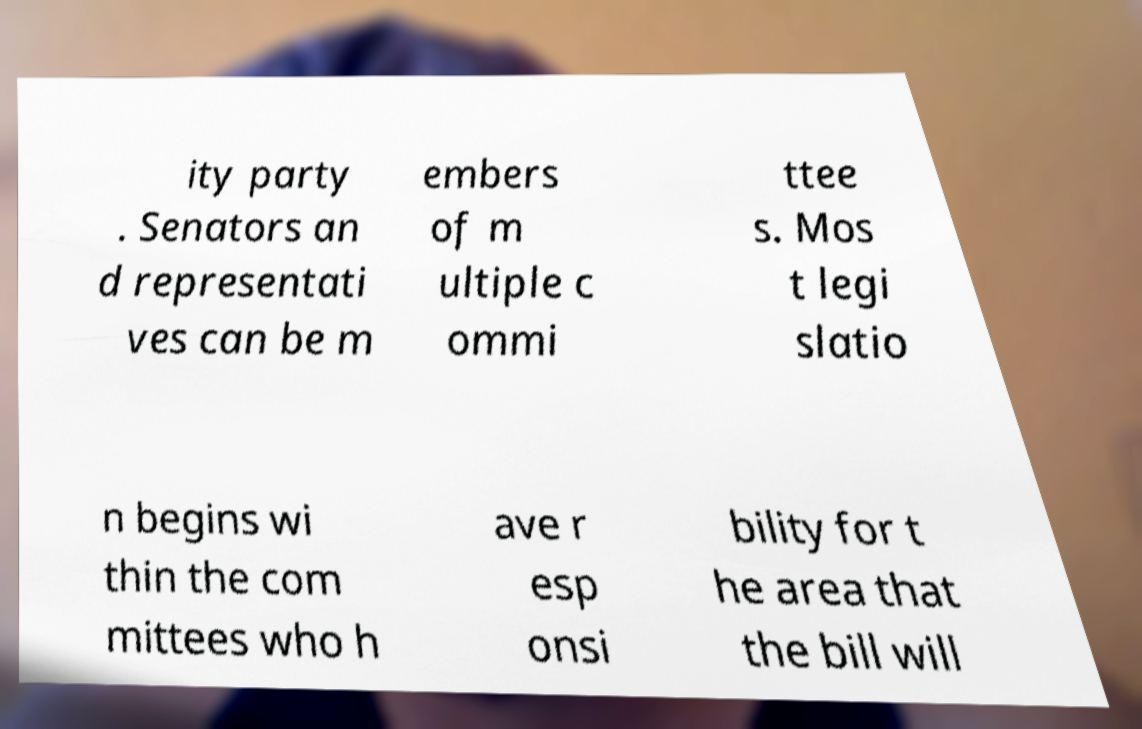There's text embedded in this image that I need extracted. Can you transcribe it verbatim? ity party . Senators an d representati ves can be m embers of m ultiple c ommi ttee s. Mos t legi slatio n begins wi thin the com mittees who h ave r esp onsi bility for t he area that the bill will 